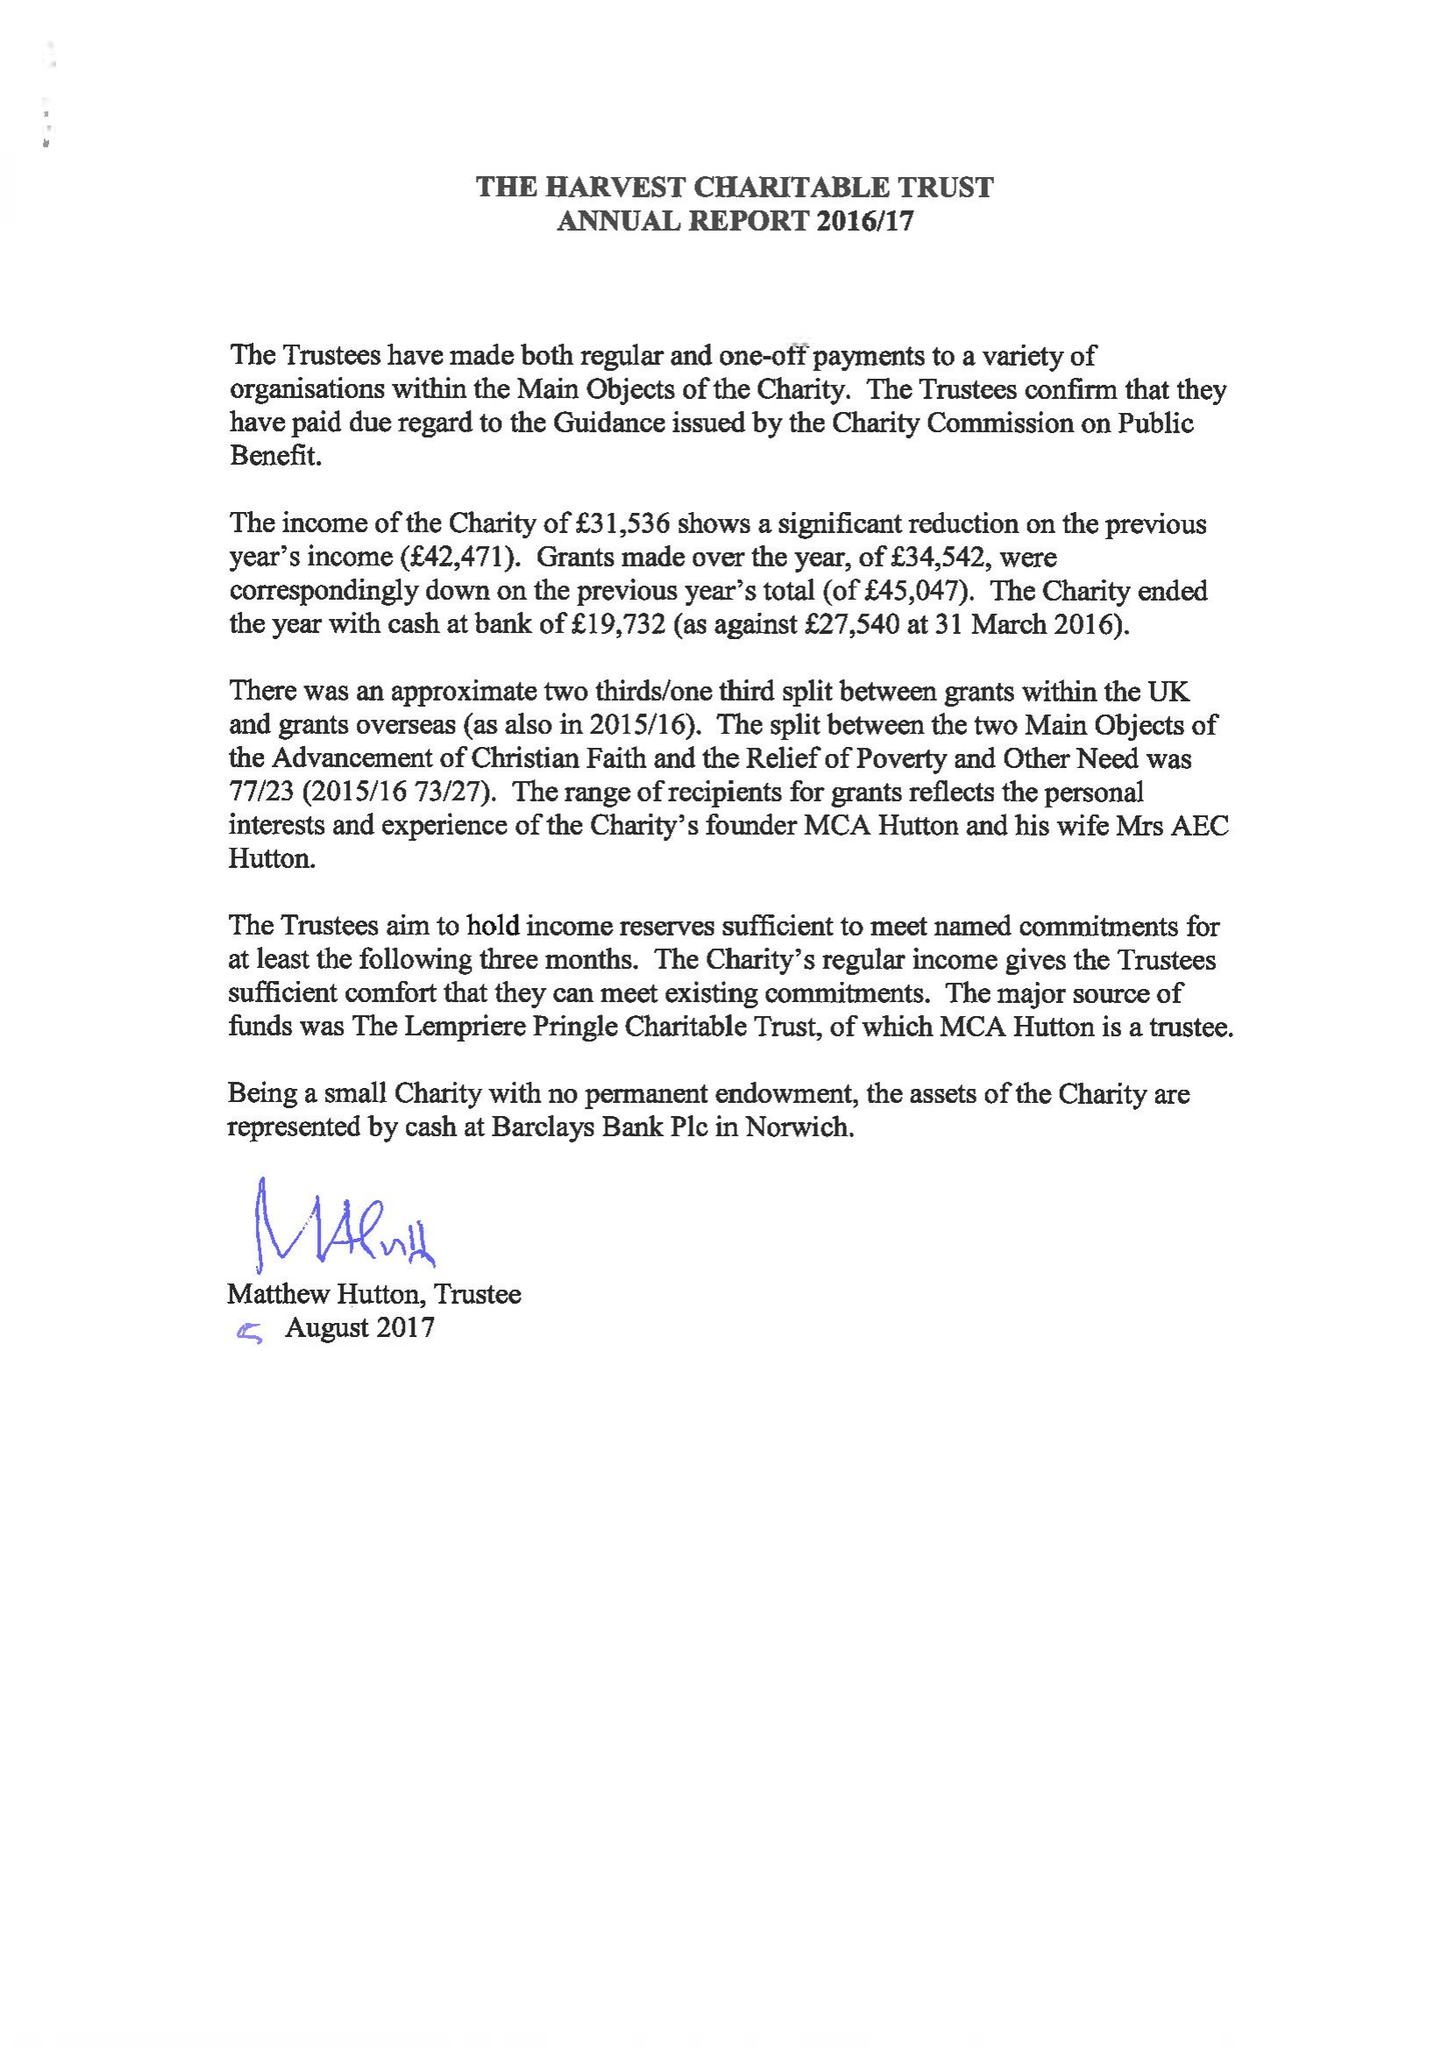What is the value for the address__post_town?
Answer the question using a single word or phrase. NORWICH 